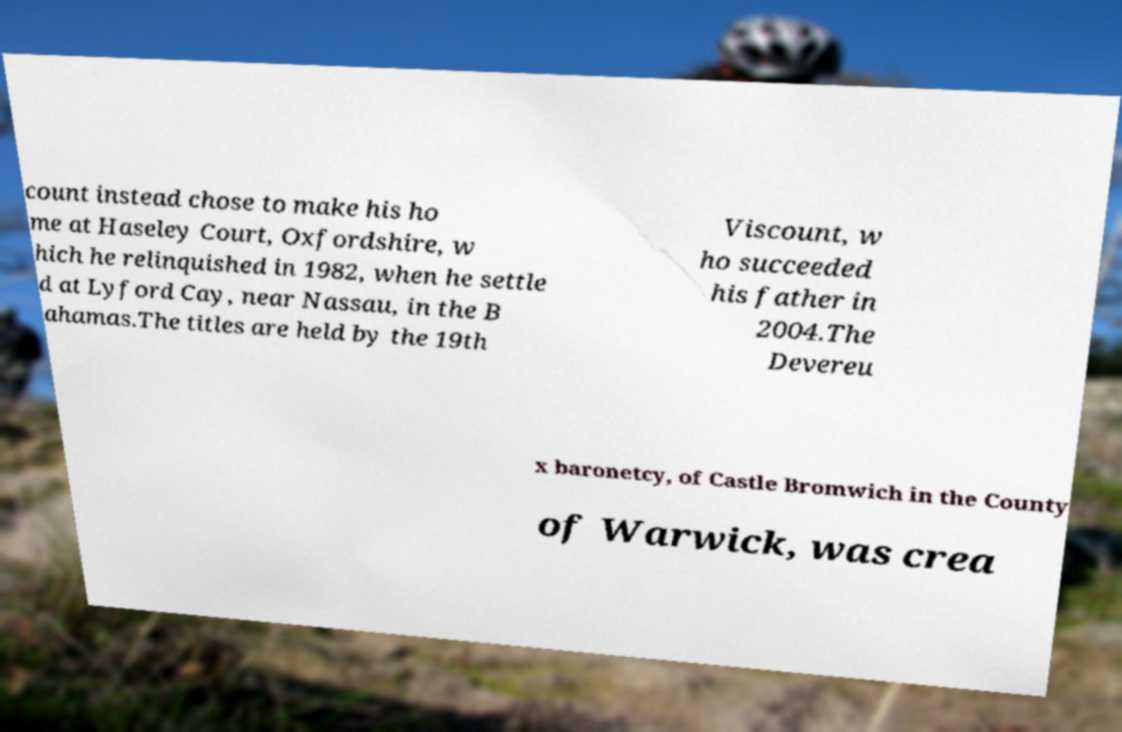Can you accurately transcribe the text from the provided image for me? count instead chose to make his ho me at Haseley Court, Oxfordshire, w hich he relinquished in 1982, when he settle d at Lyford Cay, near Nassau, in the B ahamas.The titles are held by the 19th Viscount, w ho succeeded his father in 2004.The Devereu x baronetcy, of Castle Bromwich in the County of Warwick, was crea 